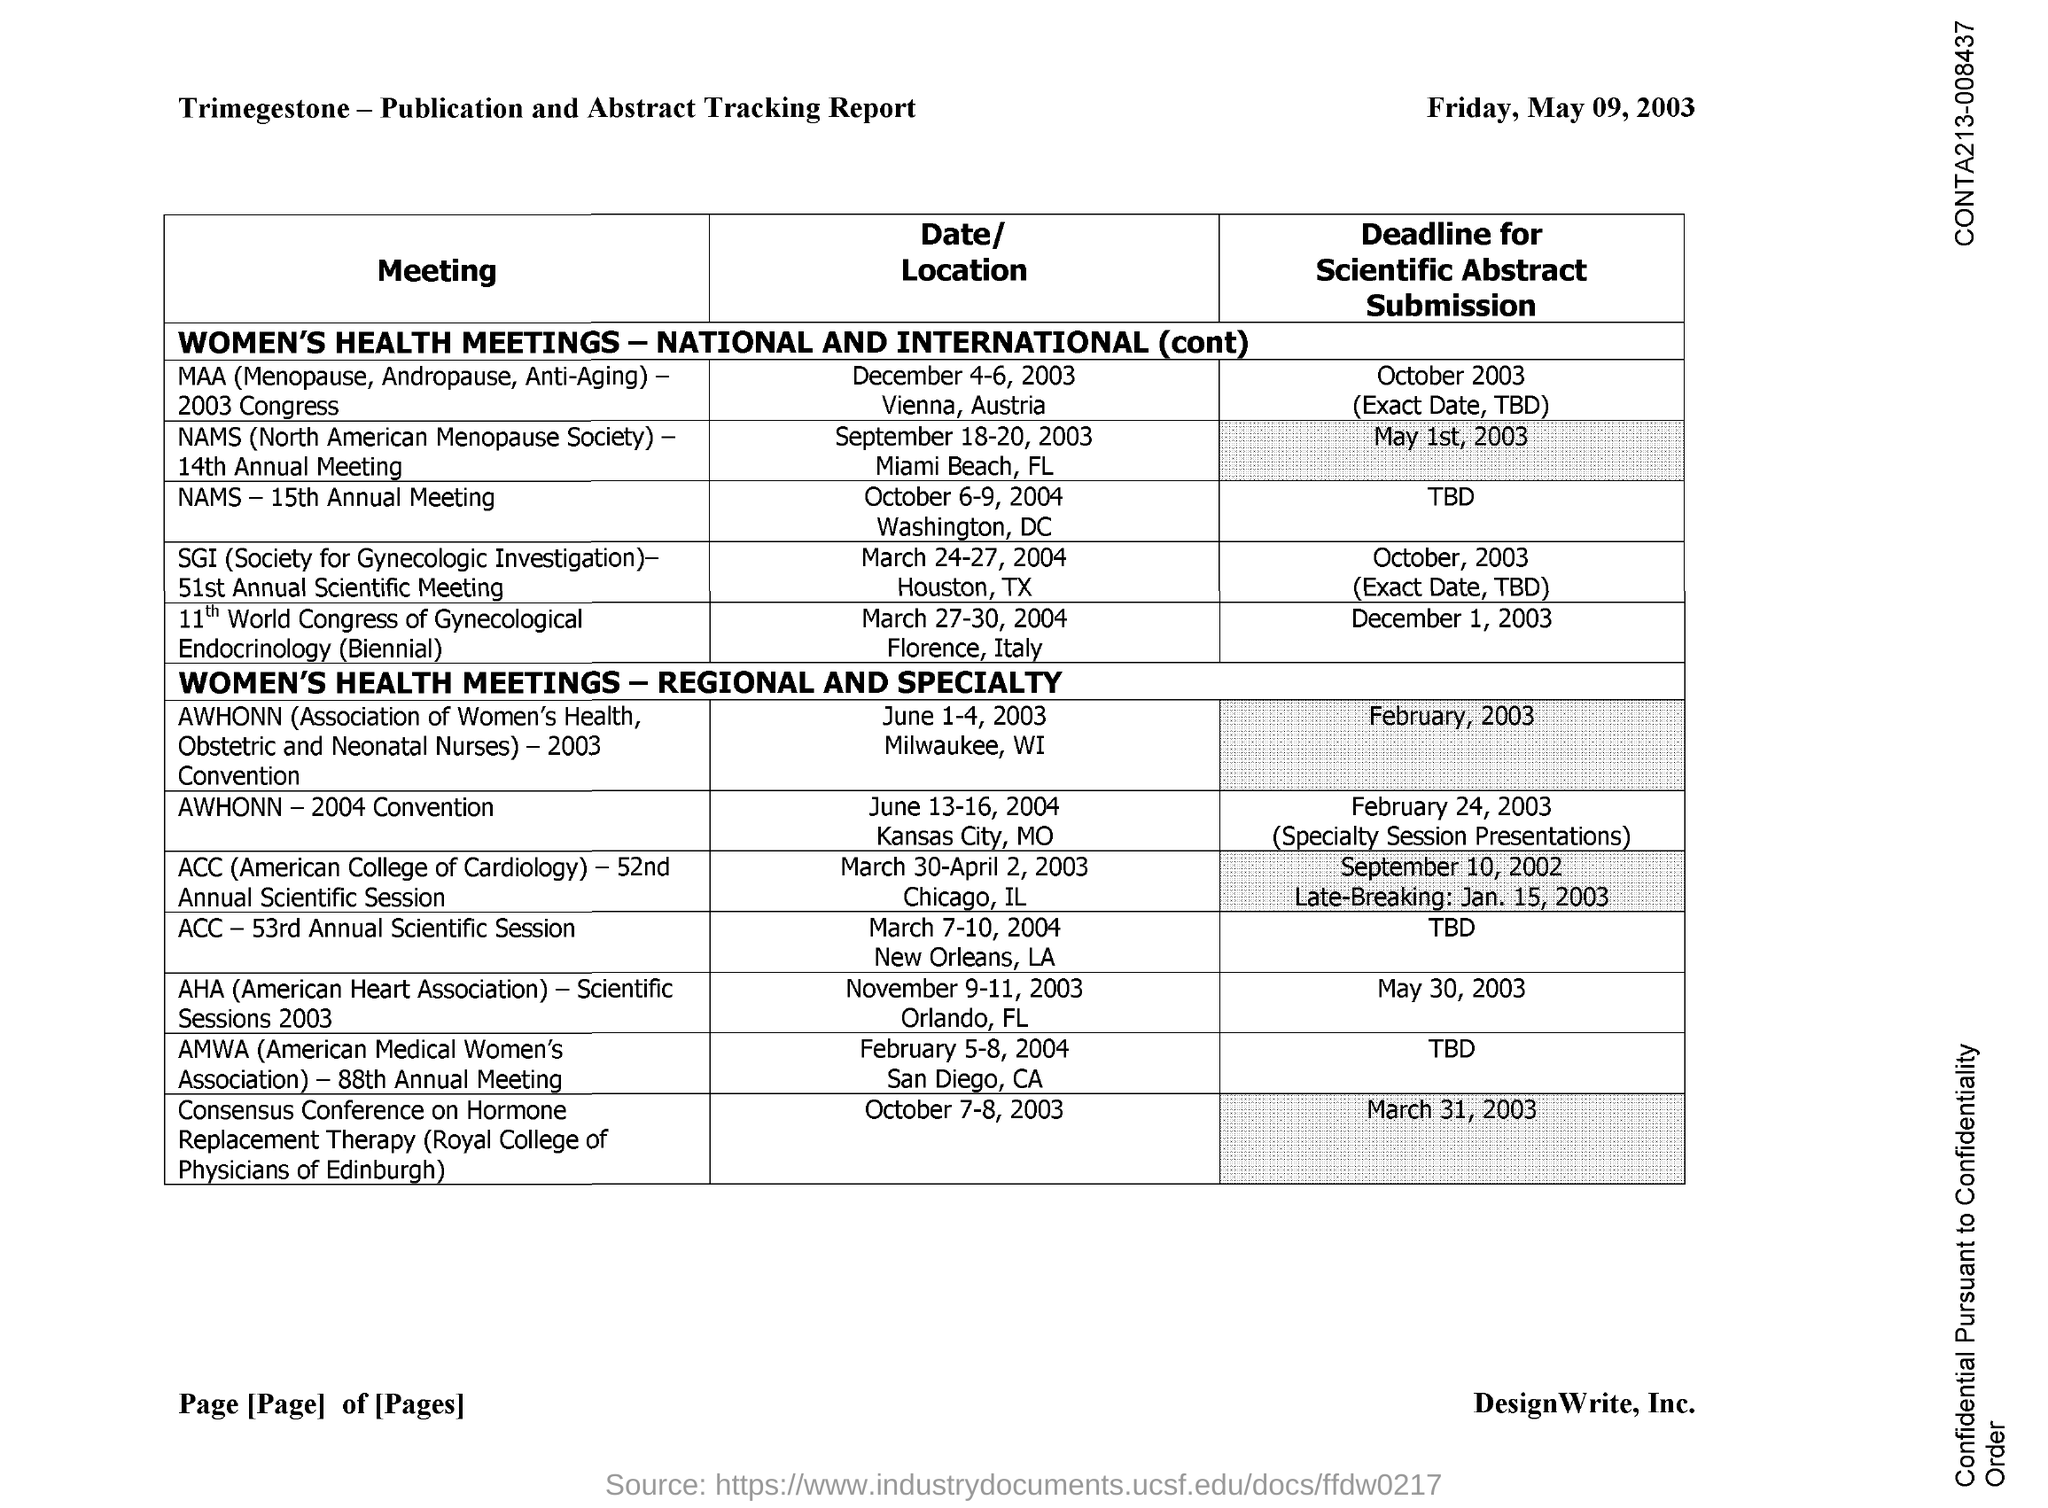Indicate a few pertinent items in this graphic. The full form of AMWA is the American Medical Women's Association. The full form of ACC is the American College of Cardiology, which is a professional organization dedicated to improving cardiovascular care and advancing the field of cardiology. The full form of AHA is American Heart Association. 